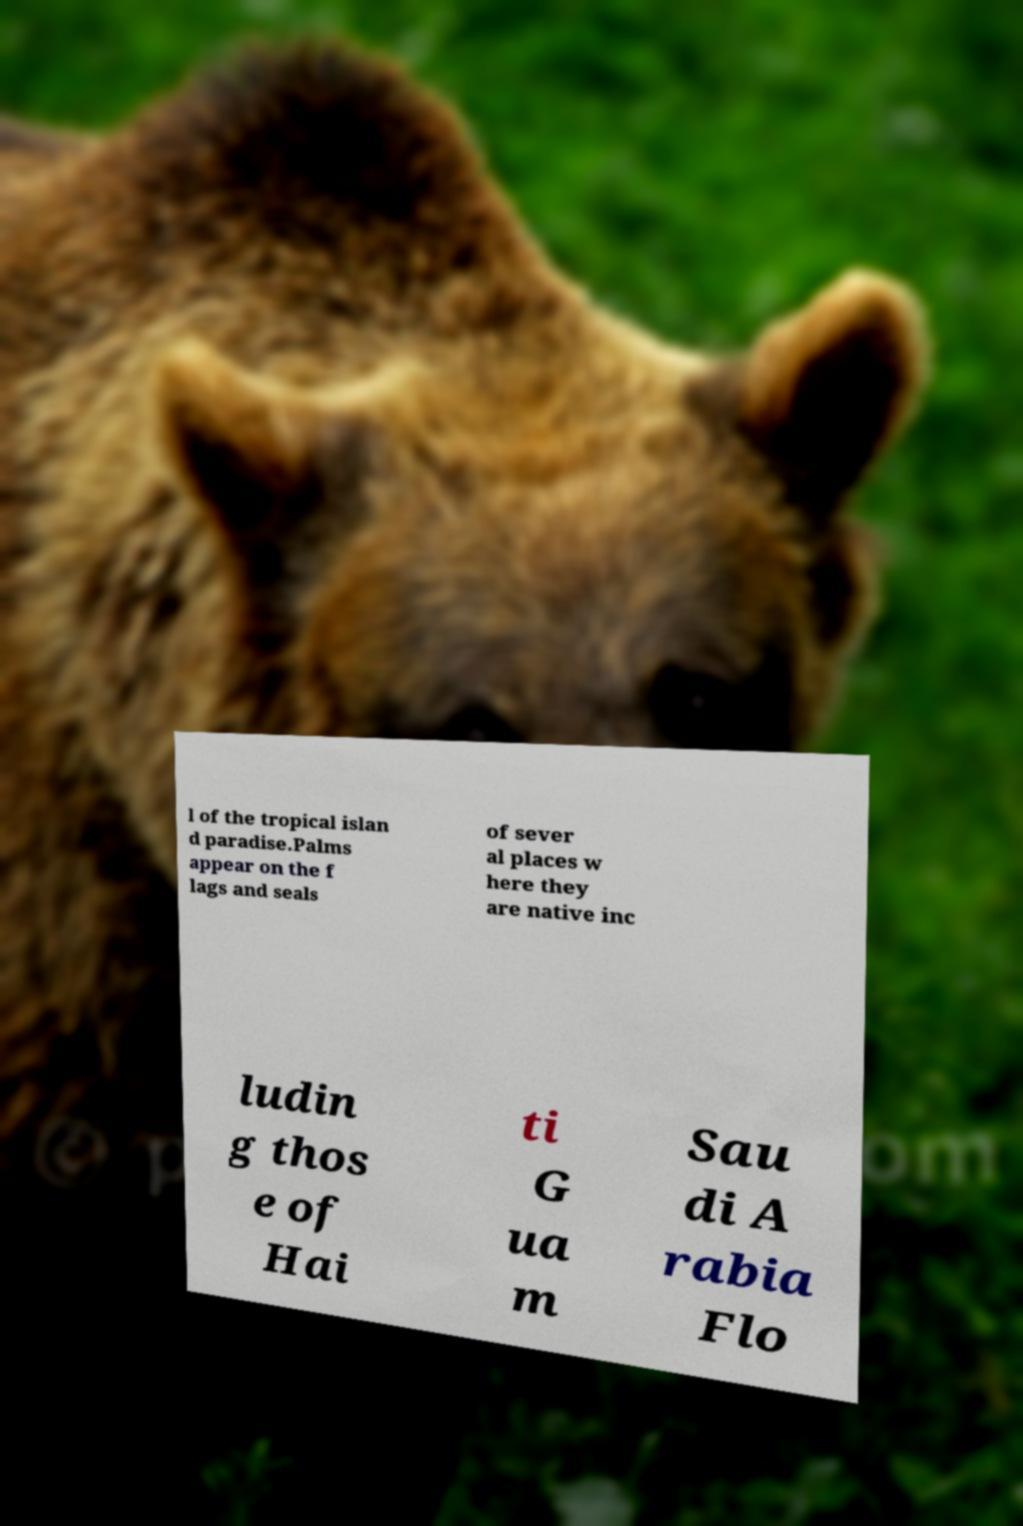For documentation purposes, I need the text within this image transcribed. Could you provide that? l of the tropical islan d paradise.Palms appear on the f lags and seals of sever al places w here they are native inc ludin g thos e of Hai ti G ua m Sau di A rabia Flo 